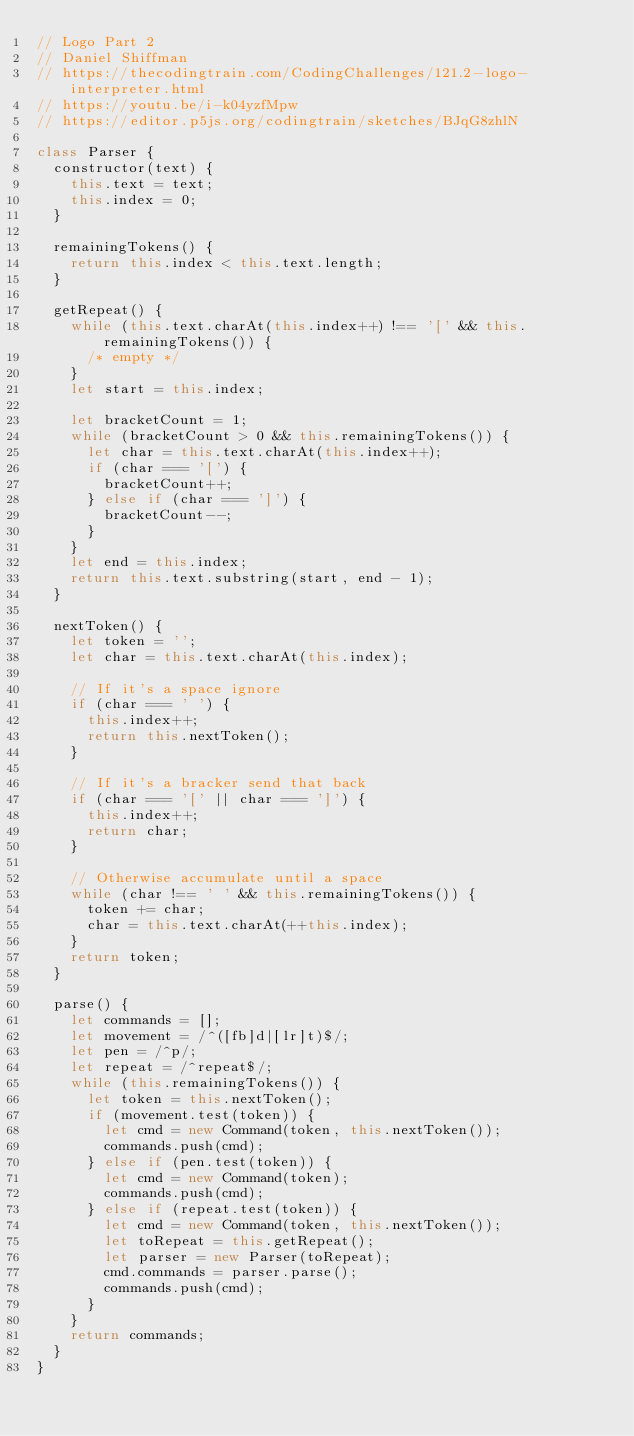<code> <loc_0><loc_0><loc_500><loc_500><_JavaScript_>// Logo Part 2
// Daniel Shiffman
// https://thecodingtrain.com/CodingChallenges/121.2-logo-interpreter.html
// https://youtu.be/i-k04yzfMpw
// https://editor.p5js.org/codingtrain/sketches/BJqG8zhlN

class Parser {
  constructor(text) {
    this.text = text;
    this.index = 0;
  }

  remainingTokens() {
    return this.index < this.text.length;
  }

  getRepeat() {
    while (this.text.charAt(this.index++) !== '[' && this.remainingTokens()) {
      /* empty */
    }
    let start = this.index;

    let bracketCount = 1;
    while (bracketCount > 0 && this.remainingTokens()) {
      let char = this.text.charAt(this.index++);
      if (char === '[') {
        bracketCount++;
      } else if (char === ']') {
        bracketCount--;
      }
    }
    let end = this.index;
    return this.text.substring(start, end - 1);
  }

  nextToken() {
    let token = '';
    let char = this.text.charAt(this.index);

    // If it's a space ignore
    if (char === ' ') {
      this.index++;
      return this.nextToken();
    }

    // If it's a bracker send that back
    if (char === '[' || char === ']') {
      this.index++;
      return char;
    }

    // Otherwise accumulate until a space
    while (char !== ' ' && this.remainingTokens()) {
      token += char;
      char = this.text.charAt(++this.index);
    }
    return token;
  }

  parse() {
    let commands = [];
    let movement = /^([fb]d|[lr]t)$/;
    let pen = /^p/;
    let repeat = /^repeat$/;
    while (this.remainingTokens()) {
      let token = this.nextToken();
      if (movement.test(token)) {
        let cmd = new Command(token, this.nextToken());
        commands.push(cmd);
      } else if (pen.test(token)) {
        let cmd = new Command(token);
        commands.push(cmd);
      } else if (repeat.test(token)) {
        let cmd = new Command(token, this.nextToken());
        let toRepeat = this.getRepeat();
        let parser = new Parser(toRepeat);
        cmd.commands = parser.parse();
        commands.push(cmd);
      }
    }
    return commands;
  }
}
</code> 